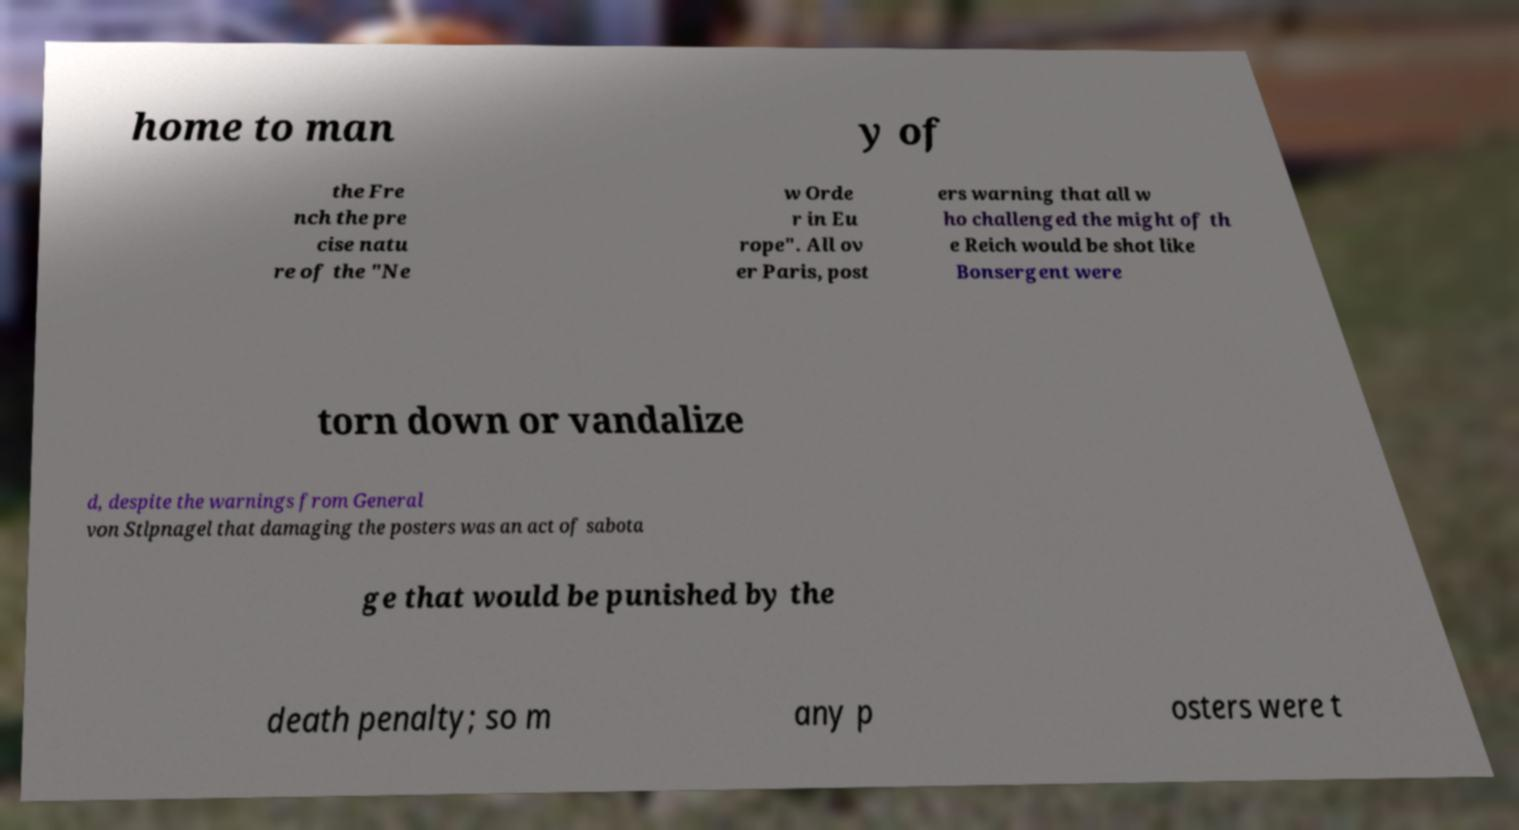For documentation purposes, I need the text within this image transcribed. Could you provide that? home to man y of the Fre nch the pre cise natu re of the "Ne w Orde r in Eu rope". All ov er Paris, post ers warning that all w ho challenged the might of th e Reich would be shot like Bonsergent were torn down or vandalize d, despite the warnings from General von Stlpnagel that damaging the posters was an act of sabota ge that would be punished by the death penalty; so m any p osters were t 